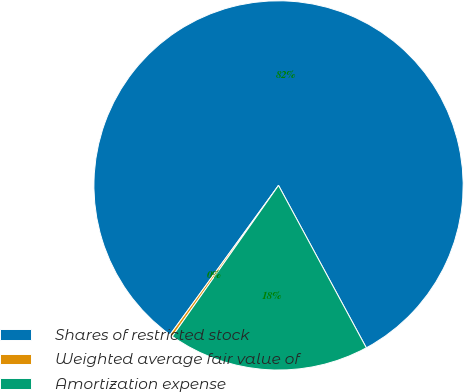Convert chart to OTSL. <chart><loc_0><loc_0><loc_500><loc_500><pie_chart><fcel>Shares of restricted stock<fcel>Weighted average fair value of<fcel>Amortization expense<nl><fcel>82.11%<fcel>0.25%<fcel>17.64%<nl></chart> 